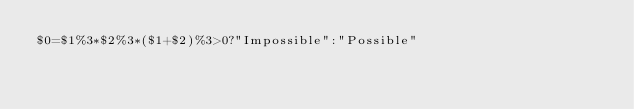Convert code to text. <code><loc_0><loc_0><loc_500><loc_500><_Awk_>$0=$1%3*$2%3*($1+$2)%3>0?"Impossible":"Possible"</code> 